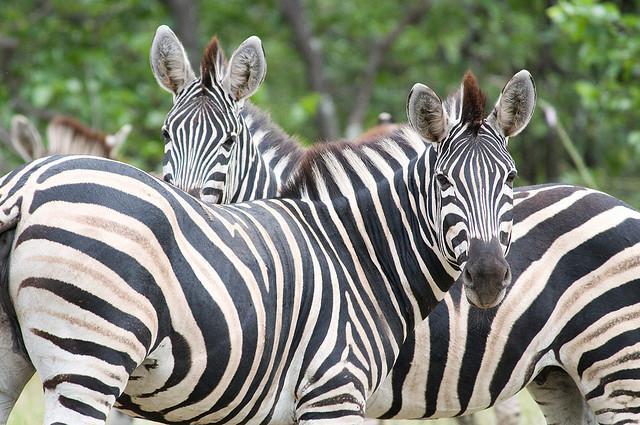How many zebra are standing next to each other?
Give a very brief answer. 2. How many zebras are in the photo?
Give a very brief answer. 4. 